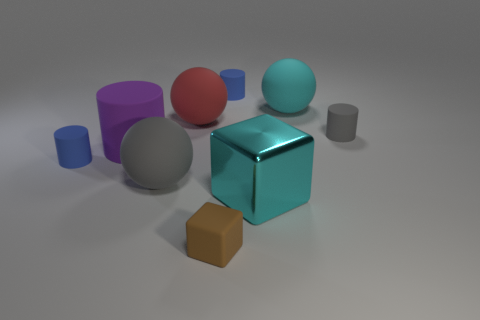Subtract 1 cylinders. How many cylinders are left? 3 Subtract all cyan cylinders. Subtract all gray balls. How many cylinders are left? 4 Subtract all spheres. How many objects are left? 6 Add 7 big purple things. How many big purple things are left? 8 Add 4 tiny objects. How many tiny objects exist? 8 Subtract 0 red cylinders. How many objects are left? 9 Subtract all gray rubber cylinders. Subtract all big yellow matte things. How many objects are left? 8 